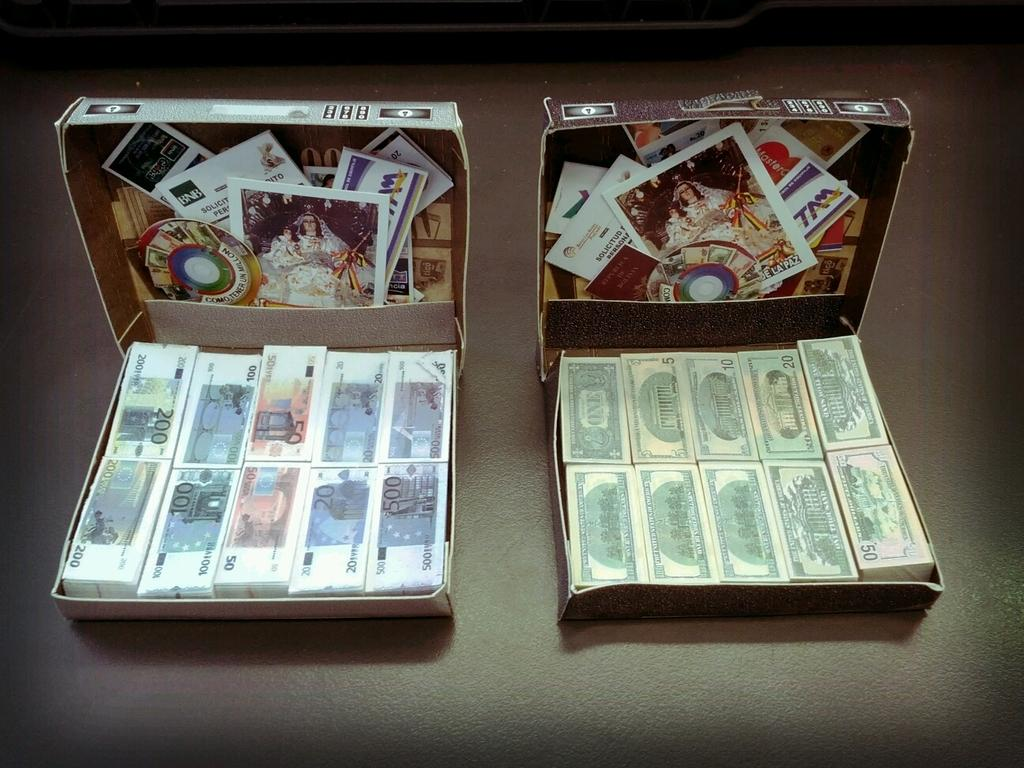<image>
Summarize the visual content of the image. Two board games showing real and fake cash for $50. 